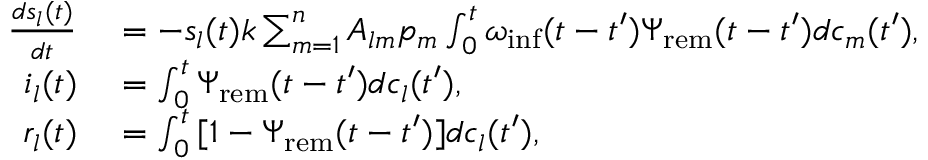<formula> <loc_0><loc_0><loc_500><loc_500>\begin{array} { r l } { \frac { d s _ { l } ( t ) } { d t } } & = - s _ { l } ( t ) k \sum _ { m = 1 } ^ { n } { A _ { l m } p _ { m } \int _ { 0 } ^ { t } { \omega _ { i n f } ( t - t ^ { \prime } ) \Psi _ { r e m } ( t - t ^ { \prime } ) d c _ { m } ( t ^ { \prime } ) } } , } \\ { i _ { l } ( t ) } & = \int _ { 0 } ^ { t } { \Psi _ { r e m } ( t - t ^ { \prime } ) d c _ { l } ( t ^ { \prime } ) } , } \\ { r _ { l } ( t ) } & = \int _ { 0 } ^ { t } { [ 1 - \Psi _ { r e m } ( t - t ^ { \prime } ) ] d c _ { l } ( t ^ { \prime } ) } , } \end{array}</formula> 